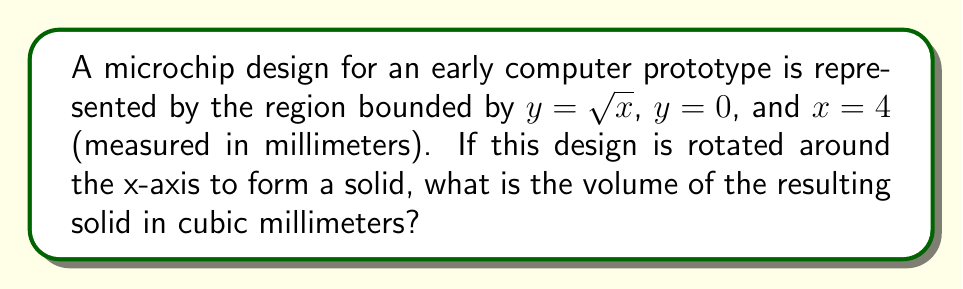Could you help me with this problem? To solve this problem, we'll use the washer method for calculating the volume of a solid of revolution. The steps are as follows:

1) The volume is given by the integral:
   $$V = \pi \int_{0}^{4} [f(x)]^2 dx$$
   where $f(x) = \sqrt{x}$

2) Substituting $f(x)$ into the formula:
   $$V = \pi \int_{0}^{4} (\sqrt{x})^2 dx = \pi \int_{0}^{4} x dx$$

3) Integrate:
   $$V = \pi [\frac{1}{2}x^2]_{0}^{4}$$

4) Evaluate the integral:
   $$V = \pi [\frac{1}{2}(4^2) - \frac{1}{2}(0^2)]$$
   $$V = \pi [8 - 0] = 8\pi$$

5) Therefore, the volume is $8\pi$ cubic millimeters.

This problem is relevant to the persona of a retired tech executive as it involves calculating the volume of a solid formed by a microchip design, which would have been a crucial aspect of early computer development.
Answer: $8\pi$ cubic millimeters 